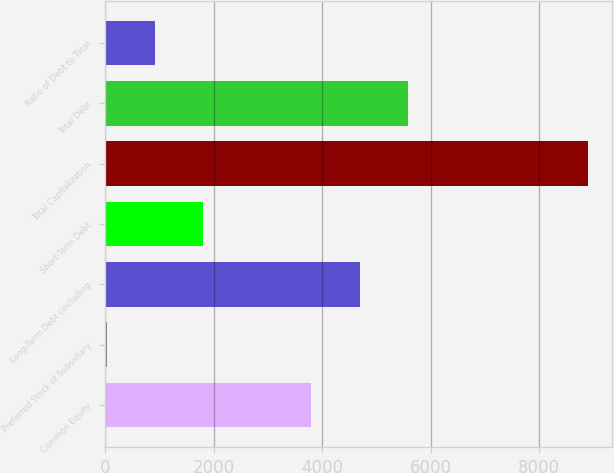Convert chart to OTSL. <chart><loc_0><loc_0><loc_500><loc_500><bar_chart><fcel>Common Equity<fcel>Preferred Stock of Subsidiary<fcel>Long-Term Debt (including<fcel>Short-Term Debt<fcel>Total Capitalization<fcel>Total Debt<fcel>Ratio of Debt to Total<nl><fcel>3802.1<fcel>30.4<fcel>4688.64<fcel>1803.48<fcel>8895.8<fcel>5575.18<fcel>916.94<nl></chart> 